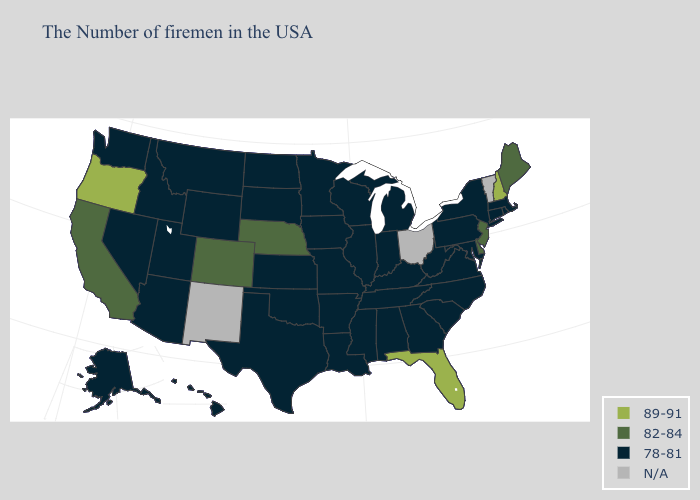Name the states that have a value in the range 82-84?
Concise answer only. Maine, New Jersey, Delaware, Nebraska, Colorado, California. Does Nevada have the highest value in the USA?
Be succinct. No. Does Connecticut have the highest value in the USA?
Be succinct. No. What is the highest value in the USA?
Answer briefly. 89-91. Name the states that have a value in the range 89-91?
Answer briefly. New Hampshire, Florida, Oregon. What is the lowest value in the USA?
Quick response, please. 78-81. What is the value of Tennessee?
Quick response, please. 78-81. Does the map have missing data?
Be succinct. Yes. Which states have the lowest value in the USA?
Quick response, please. Massachusetts, Rhode Island, Connecticut, New York, Maryland, Pennsylvania, Virginia, North Carolina, South Carolina, West Virginia, Georgia, Michigan, Kentucky, Indiana, Alabama, Tennessee, Wisconsin, Illinois, Mississippi, Louisiana, Missouri, Arkansas, Minnesota, Iowa, Kansas, Oklahoma, Texas, South Dakota, North Dakota, Wyoming, Utah, Montana, Arizona, Idaho, Nevada, Washington, Alaska, Hawaii. Does Nebraska have the lowest value in the MidWest?
Be succinct. No. What is the value of Missouri?
Answer briefly. 78-81. What is the highest value in the USA?
Answer briefly. 89-91. What is the highest value in states that border Minnesota?
Short answer required. 78-81. What is the value of Florida?
Give a very brief answer. 89-91. 